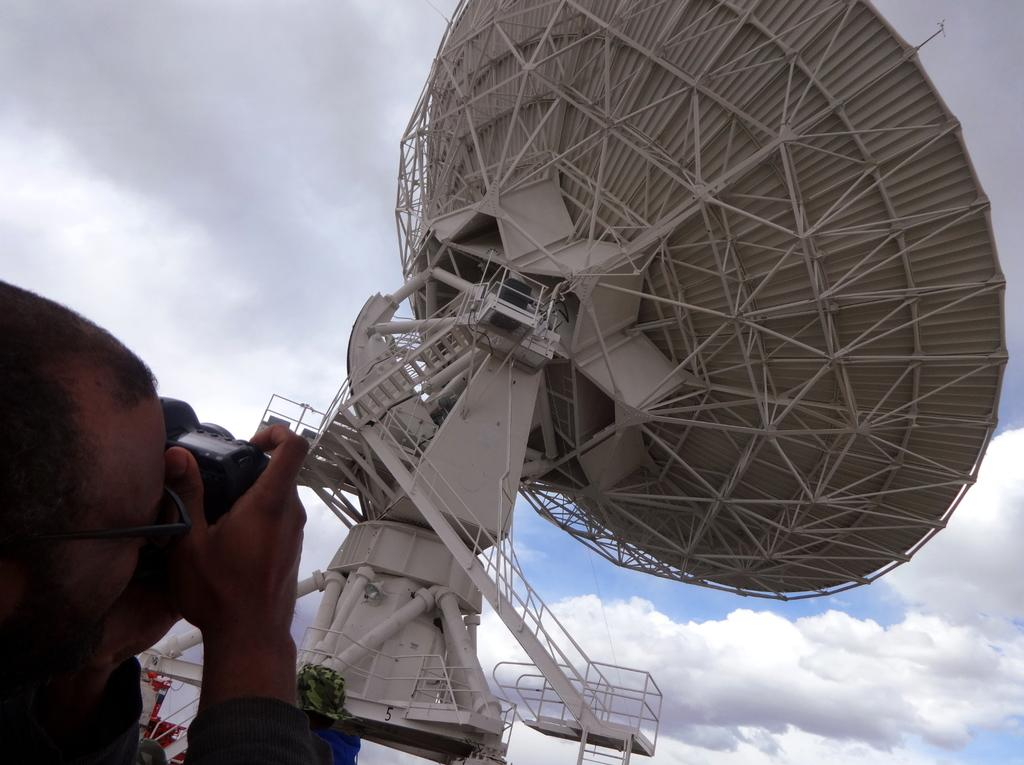Who is the main subject in the image? There is a man in the image. What is the man holding in the image? The man is holding a camera. What is the man taking a picture of? The man is taking a picture of an antenna. What can be seen in the background of the image? The sky is visible in the image. Where is the kitty going on vacation in the image? There is no kitty or vacation mentioned in the image; it features a man taking a picture of an antenna. 